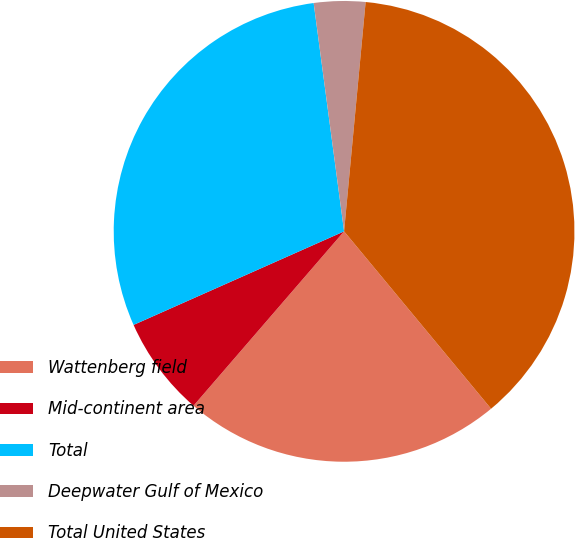<chart> <loc_0><loc_0><loc_500><loc_500><pie_chart><fcel>Wattenberg field<fcel>Mid-continent area<fcel>Total<fcel>Deepwater Gulf of Mexico<fcel>Total United States<nl><fcel>22.35%<fcel>7.01%<fcel>29.55%<fcel>3.6%<fcel>37.5%<nl></chart> 